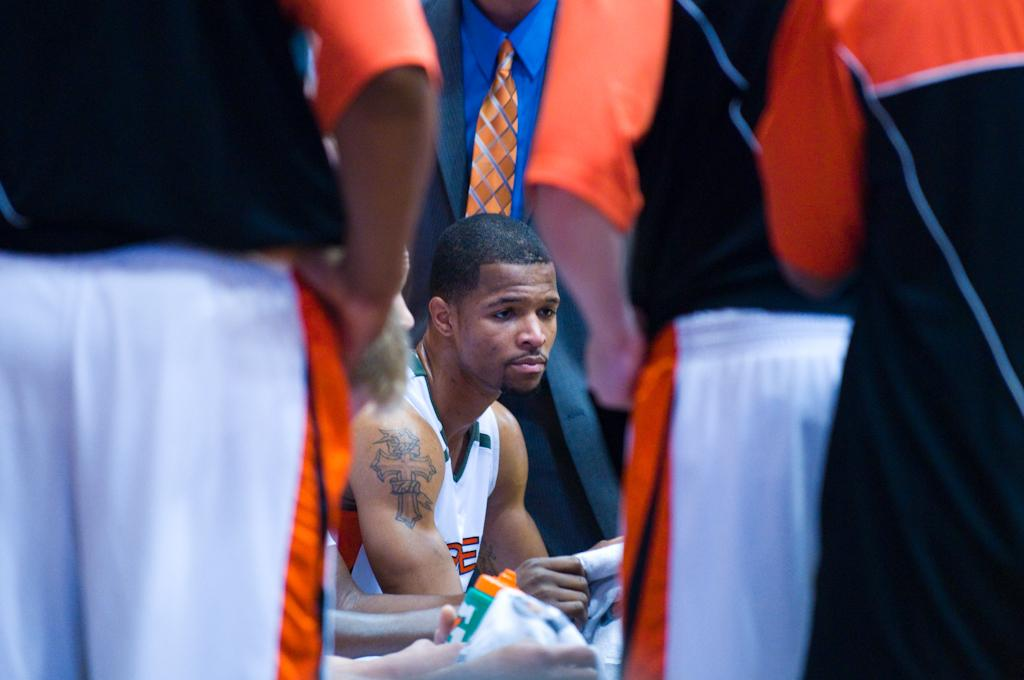Who is present in the image? There are people in the image. What are the people wearing? The people are wearing sports dress. Are any of the people holding anything? Yes, some people are holding objects. Can you describe the attire of one person in the image? There is a person wearing a coat and a tie. What type of fruit can be seen on the beds in the image? There are no beds or fruit present in the image. 